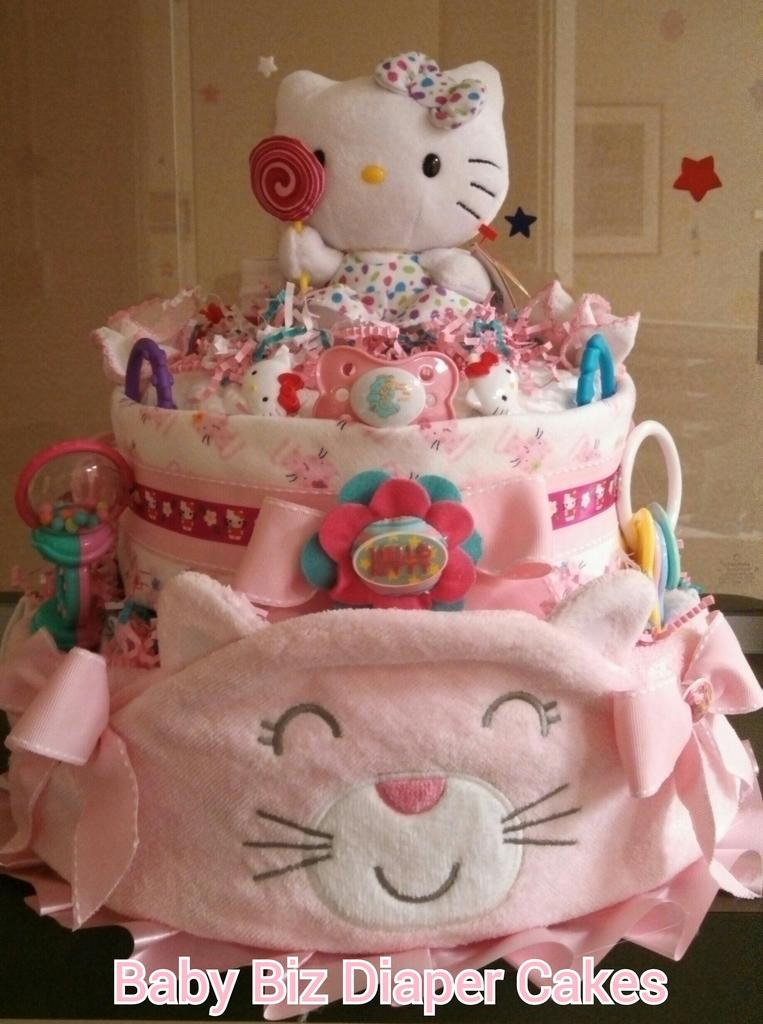What objects can be seen in the image? There are toys in the image. What else can be seen in the background of the image? There is a photo frame in the background of the image. How many dresses are hanging on the wall in the image? There is no dress present in the image; it only features toys and a photo frame. What type of spiders can be seen crawling on the toys in the image? There are no spiders present in the image; it only features toys and a photo frame. 